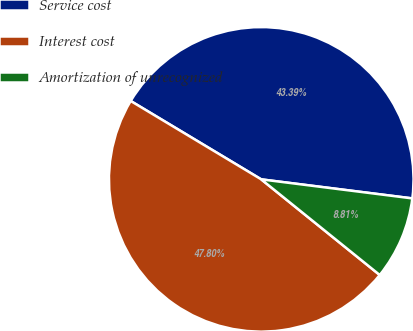Convert chart to OTSL. <chart><loc_0><loc_0><loc_500><loc_500><pie_chart><fcel>Service cost<fcel>Interest cost<fcel>Amortization of unrecognized<nl><fcel>43.39%<fcel>47.8%<fcel>8.81%<nl></chart> 